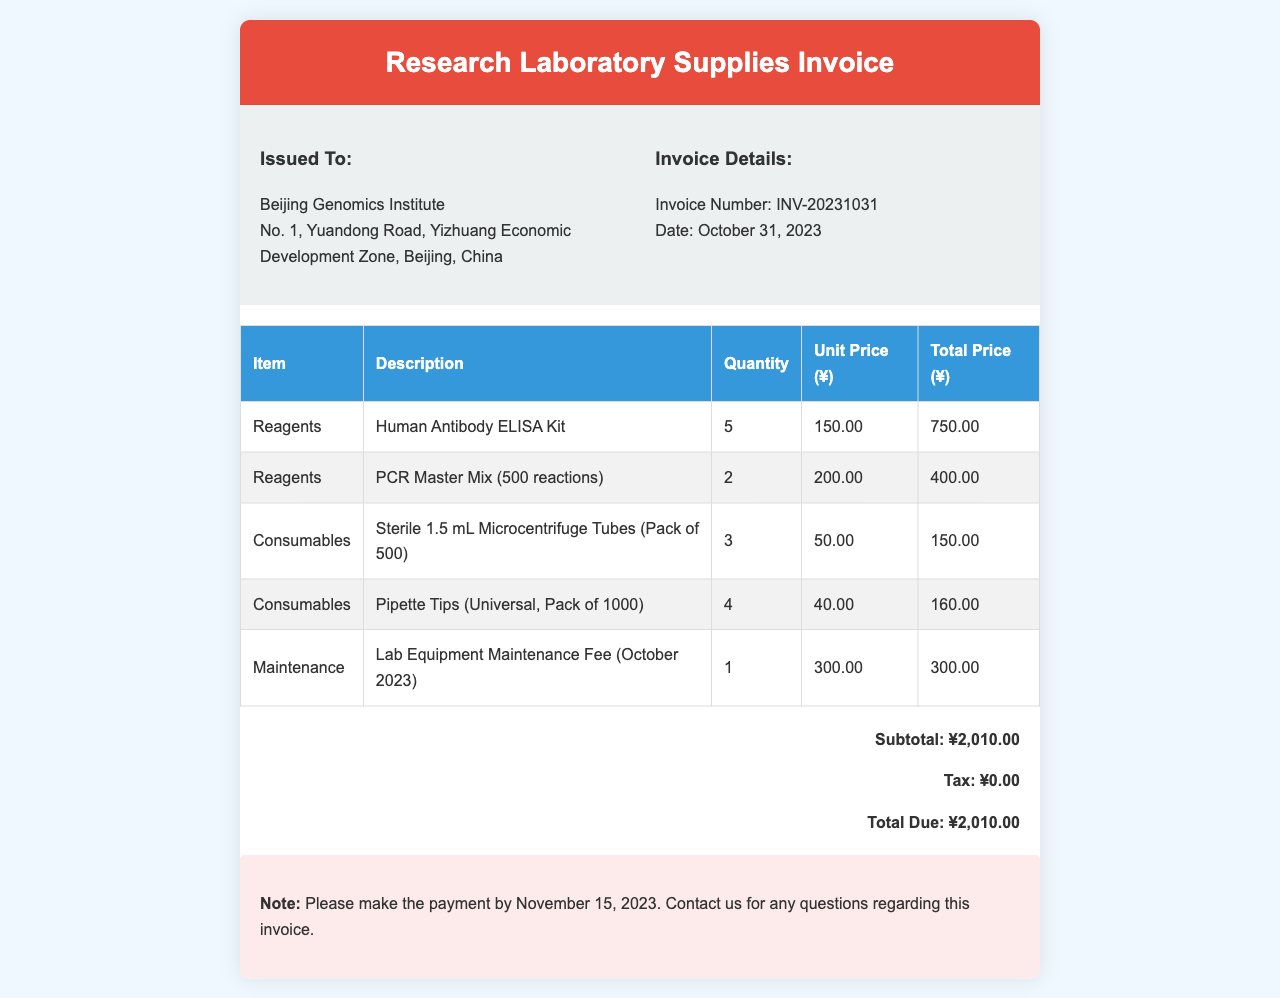What is the invoice number? The invoice number is listed under Invoice Details in the document.
Answer: INV-20231031 What is the total due amount? The total due amount is found in the invoice summary section.
Answer: ¥2,010.00 How many Human Antibody ELISA Kits were ordered? The quantity of Human Antibody ELISA Kits is provided in the item description of the invoice table.
Answer: 5 What is the unit price of the PCR Master Mix? The unit price can be located in the invoice table associated with the PCR Master Mix item.
Answer: ¥200.00 What is the maintenance fee for October 2023? The maintenance fee is noted specifically in the invoice table.
Answer: ¥300.00 How many pipette tips were ordered? The quantity for pipette tips is listed in the invoice table under consumables.
Answer: 4 When is the payment due? This information is found in the notes section at the bottom of the invoice.
Answer: November 15, 2023 What is the subtotal listed in the invoice? The subtotal is clearly outlined in the invoice summary section.
Answer: ¥2,010.00 What is the description for the first item in the invoice? The description is provided next to the Human Antibody ELISA Kit in the invoice table.
Answer: Human Antibody ELISA Kit 